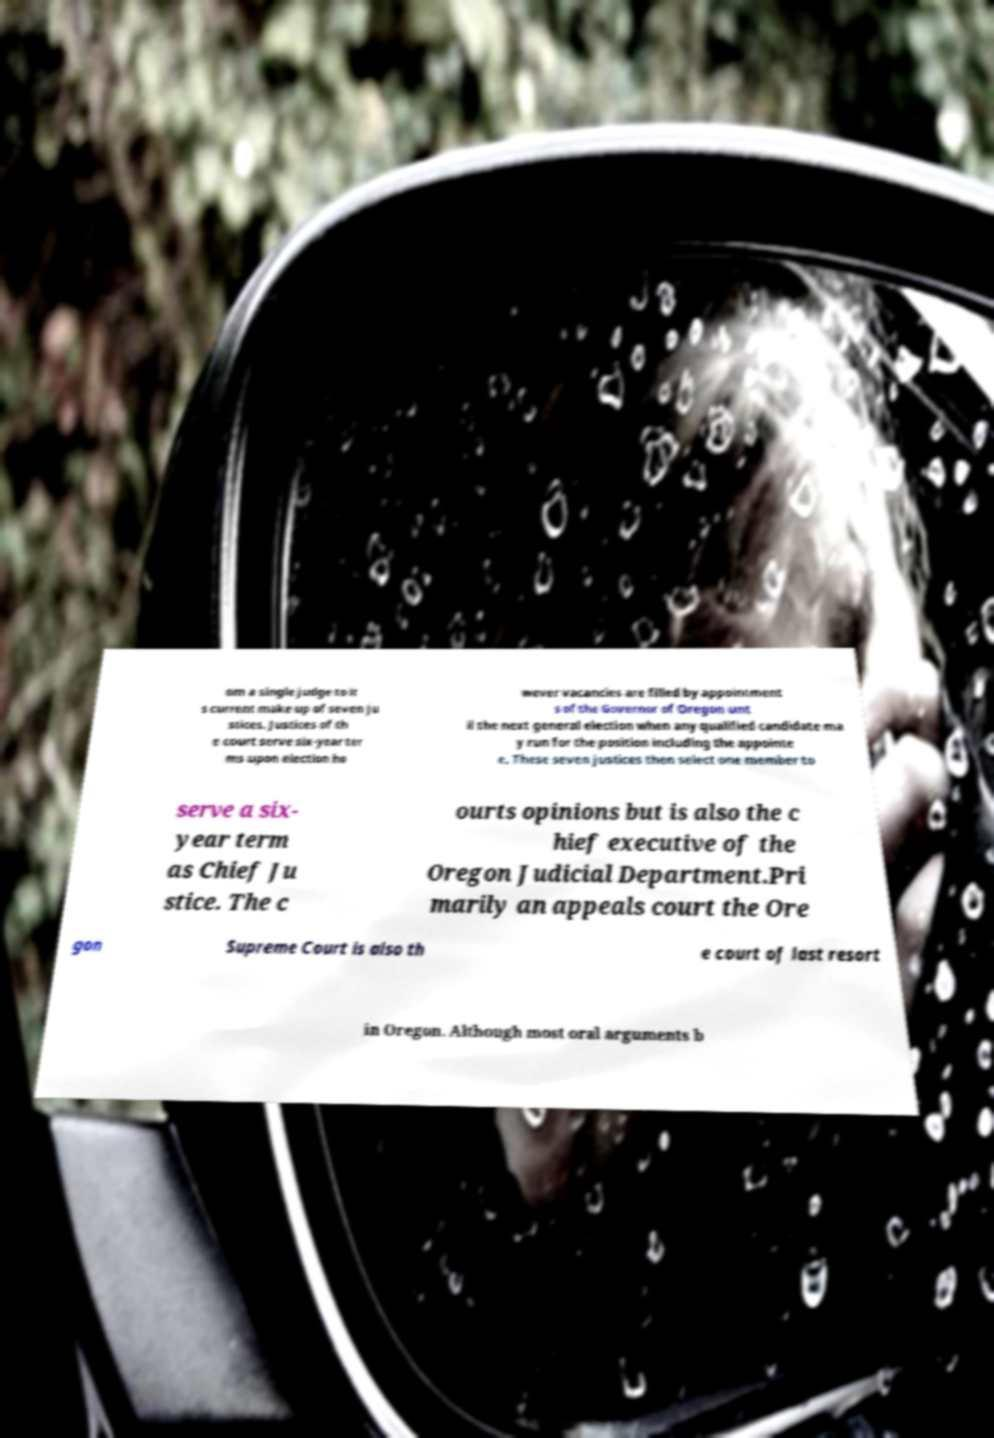There's text embedded in this image that I need extracted. Can you transcribe it verbatim? om a single judge to it s current make up of seven ju stices. Justices of th e court serve six-year ter ms upon election ho wever vacancies are filled by appointment s of the Governor of Oregon unt il the next general election when any qualified candidate ma y run for the position including the appointe e. These seven justices then select one member to serve a six- year term as Chief Ju stice. The c ourts opinions but is also the c hief executive of the Oregon Judicial Department.Pri marily an appeals court the Ore gon Supreme Court is also th e court of last resort in Oregon. Although most oral arguments b 